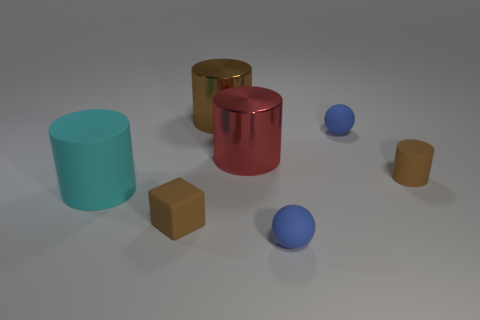Add 3 cyan rubber cylinders. How many objects exist? 10 Subtract all spheres. How many objects are left? 5 Subtract 1 brown blocks. How many objects are left? 6 Subtract all gray cubes. Subtract all brown metallic things. How many objects are left? 6 Add 3 big brown shiny cylinders. How many big brown shiny cylinders are left? 4 Add 6 yellow rubber cylinders. How many yellow rubber cylinders exist? 6 